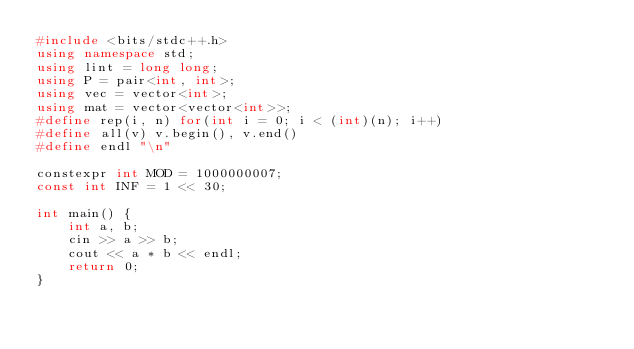Convert code to text. <code><loc_0><loc_0><loc_500><loc_500><_C++_>#include <bits/stdc++.h>
using namespace std;
using lint = long long;
using P = pair<int, int>;
using vec = vector<int>;
using mat = vector<vector<int>>;
#define rep(i, n) for(int i = 0; i < (int)(n); i++)
#define all(v) v.begin(), v.end()
#define endl "\n"

constexpr int MOD = 1000000007;
const int INF = 1 << 30;

int main() {
    int a, b;
    cin >> a >> b;
    cout << a * b << endl;
    return 0;
}</code> 